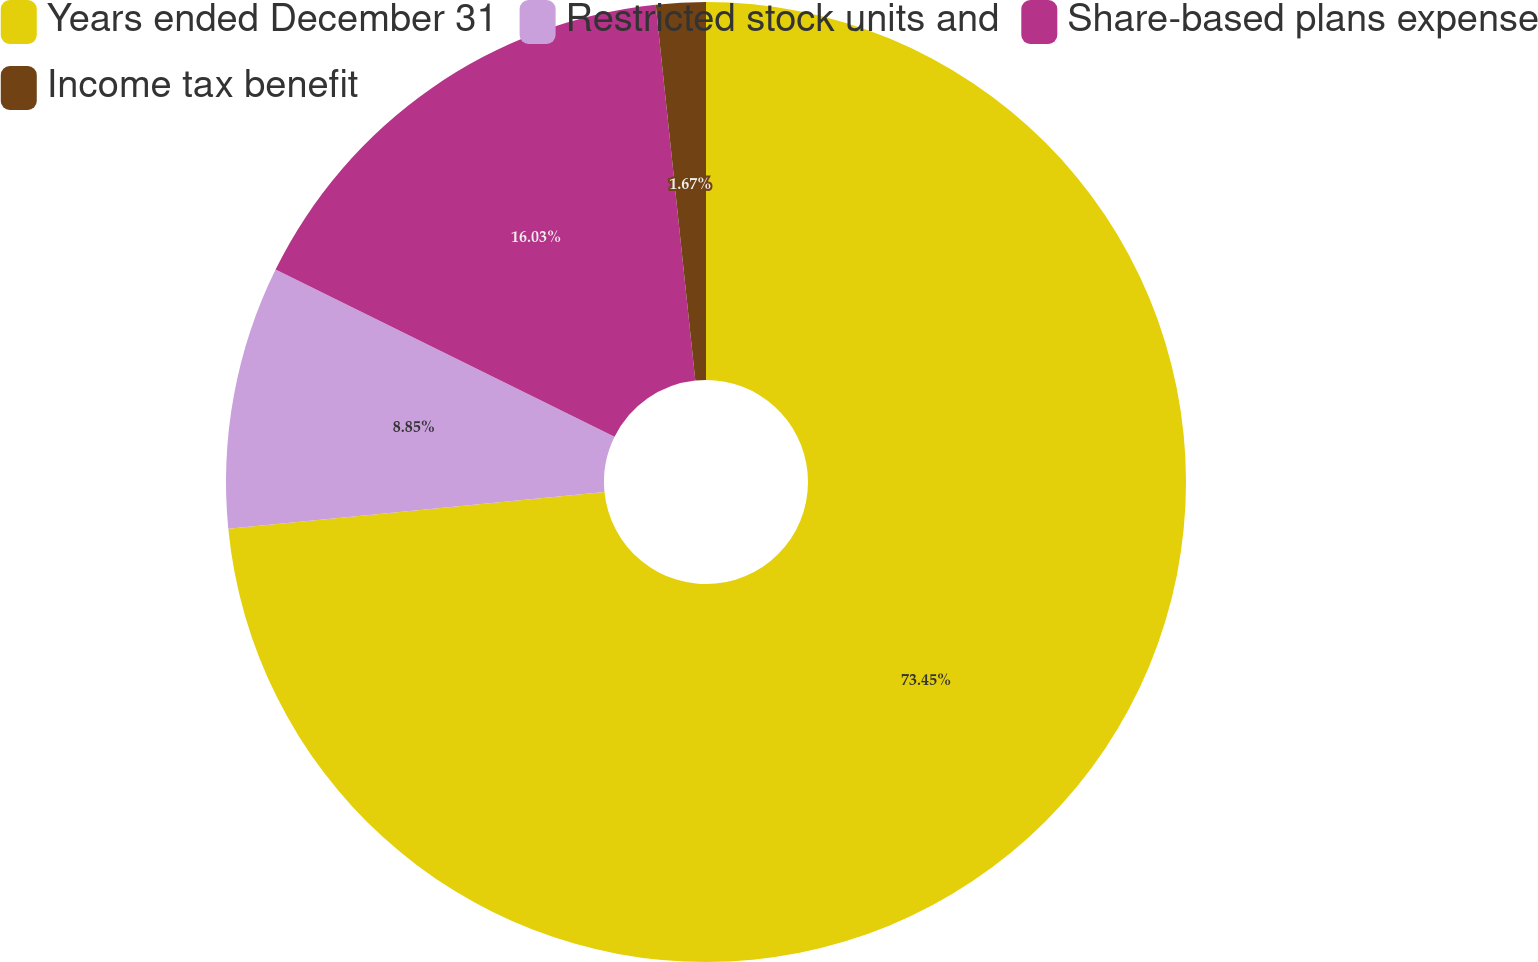Convert chart to OTSL. <chart><loc_0><loc_0><loc_500><loc_500><pie_chart><fcel>Years ended December 31<fcel>Restricted stock units and<fcel>Share-based plans expense<fcel>Income tax benefit<nl><fcel>73.44%<fcel>8.85%<fcel>16.03%<fcel>1.67%<nl></chart> 